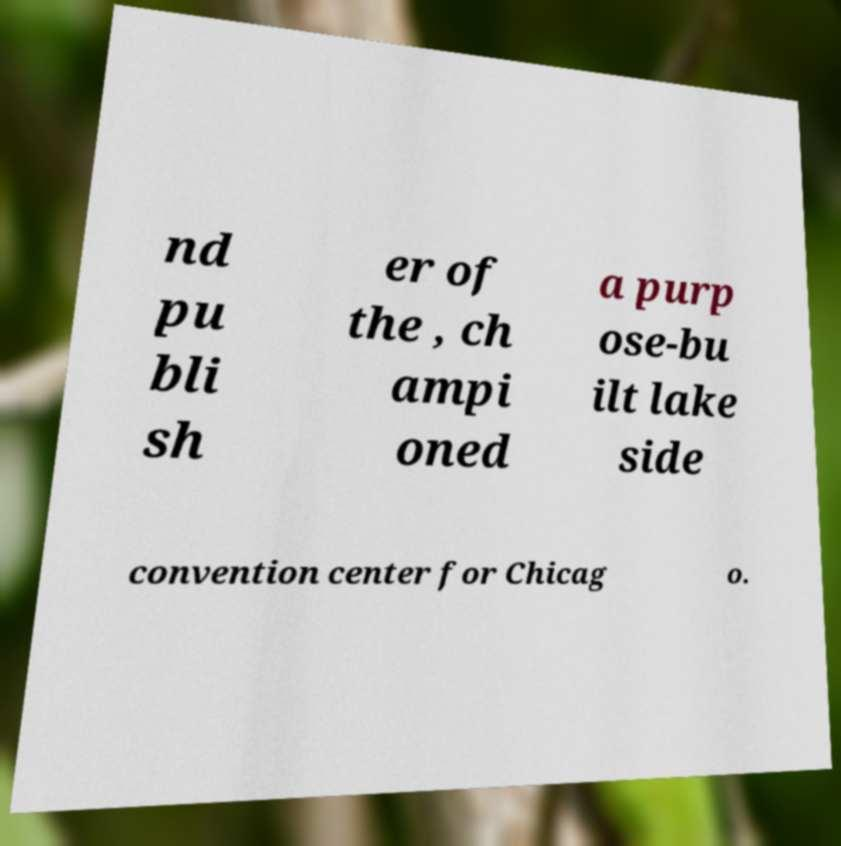There's text embedded in this image that I need extracted. Can you transcribe it verbatim? nd pu bli sh er of the , ch ampi oned a purp ose-bu ilt lake side convention center for Chicag o. 